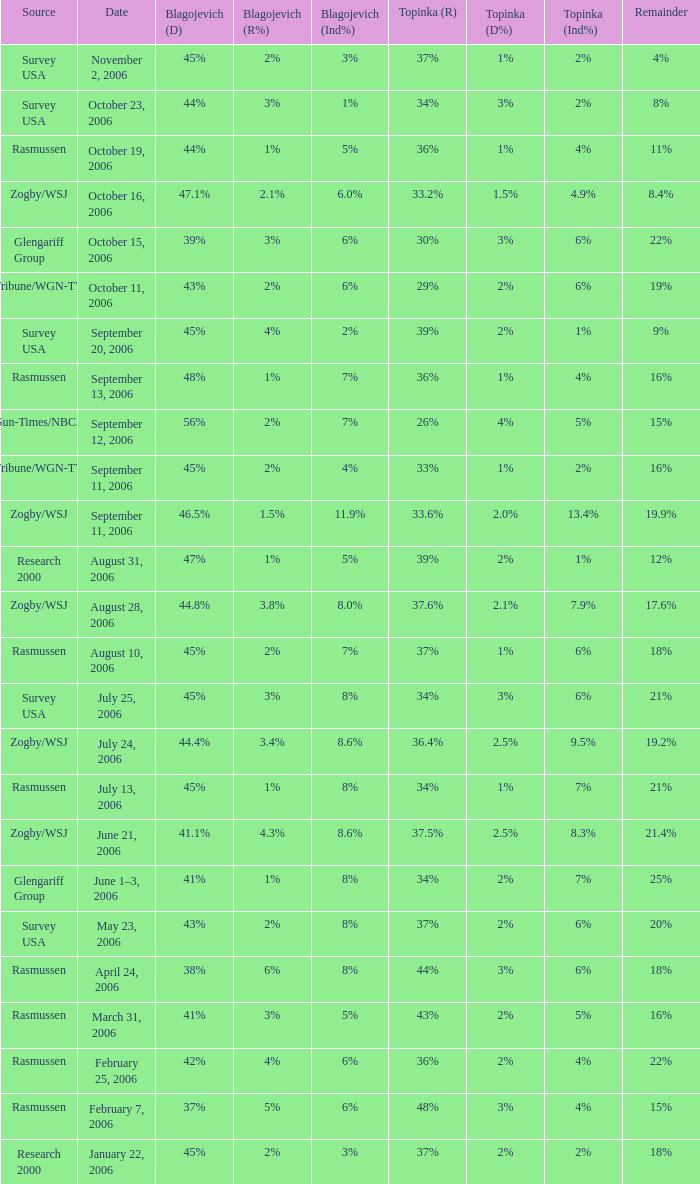Which Topinka happened on january 22, 2006? 37%. 